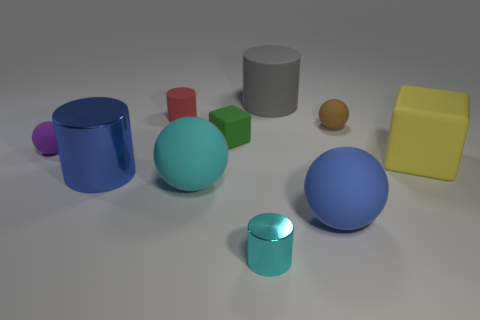What material is the sphere that is the same color as the big metal cylinder?
Keep it short and to the point. Rubber. There is another tiny object that is the same shape as the yellow object; what color is it?
Provide a succinct answer. Green. Does the blue shiny object have the same shape as the tiny red thing?
Make the answer very short. Yes. What number of other things are there of the same material as the purple object
Give a very brief answer. 7. How many big yellow rubber objects are the same shape as the big cyan matte object?
Offer a very short reply. 0. The big matte object that is both left of the big blue ball and in front of the gray rubber object is what color?
Keep it short and to the point. Cyan. How many tiny red things are there?
Keep it short and to the point. 1. Does the blue metal cylinder have the same size as the blue matte thing?
Your answer should be very brief. Yes. Is there a small metallic cylinder that has the same color as the big metallic cylinder?
Make the answer very short. No. Is the shape of the brown rubber object in front of the tiny red rubber object the same as  the small green thing?
Your answer should be very brief. No. 